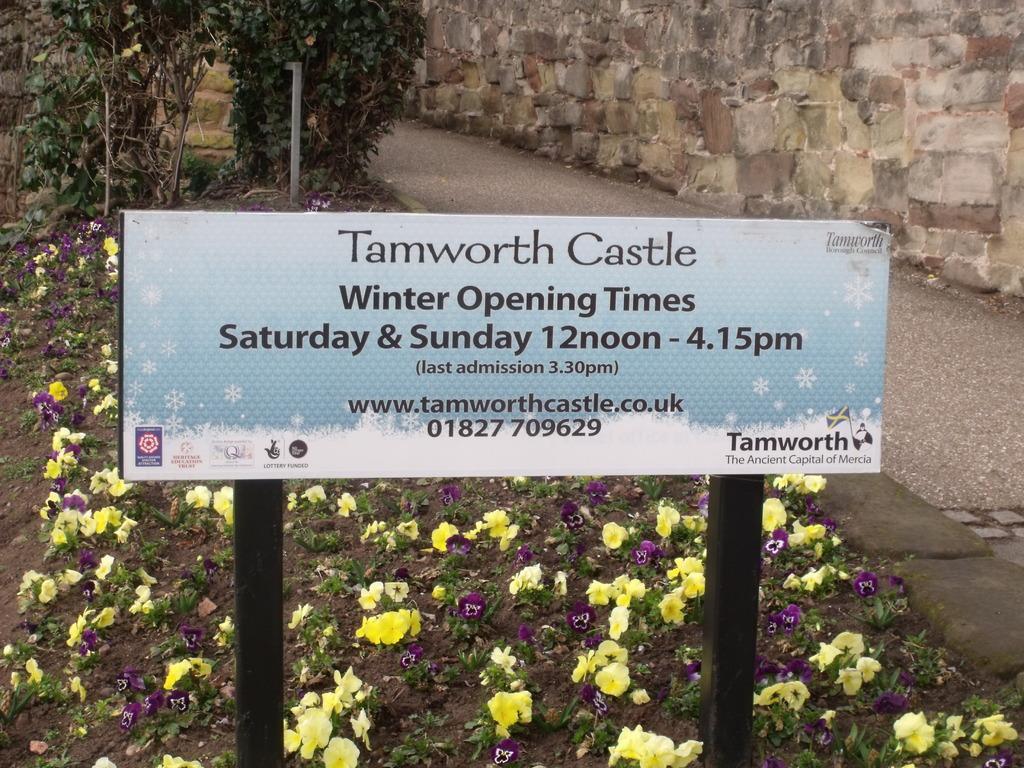How would you summarize this image in a sentence or two? In this image we can see a board with some text and there are some plants, trees and flowers. On the right side of the image we can see the path and there is a wall. 